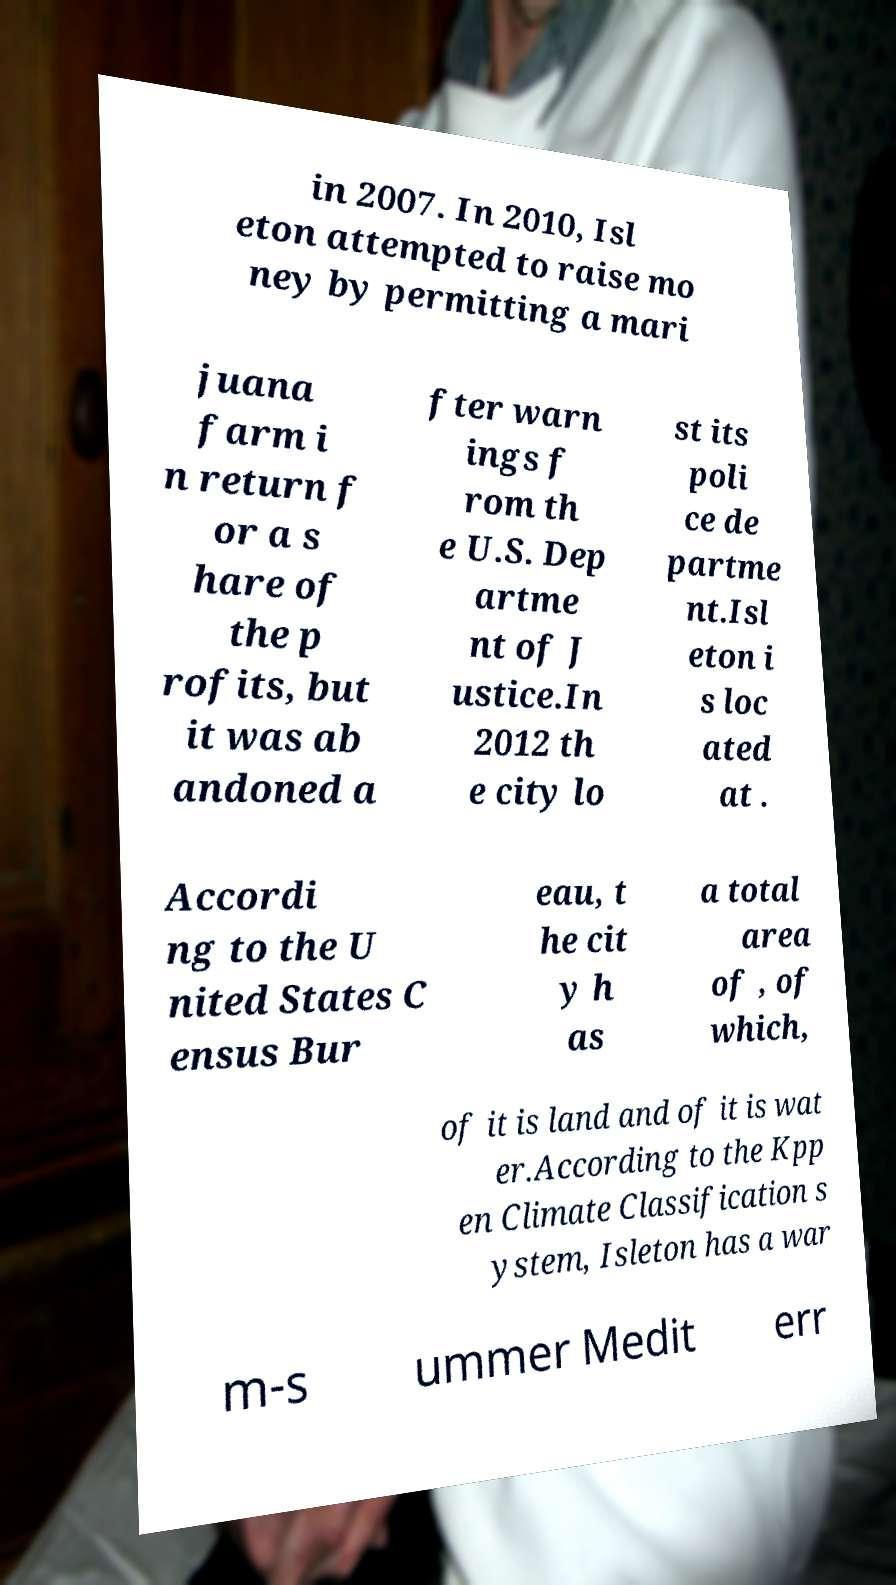What messages or text are displayed in this image? I need them in a readable, typed format. in 2007. In 2010, Isl eton attempted to raise mo ney by permitting a mari juana farm i n return f or a s hare of the p rofits, but it was ab andoned a fter warn ings f rom th e U.S. Dep artme nt of J ustice.In 2012 th e city lo st its poli ce de partme nt.Isl eton i s loc ated at . Accordi ng to the U nited States C ensus Bur eau, t he cit y h as a total area of , of which, of it is land and of it is wat er.According to the Kpp en Climate Classification s ystem, Isleton has a war m-s ummer Medit err 